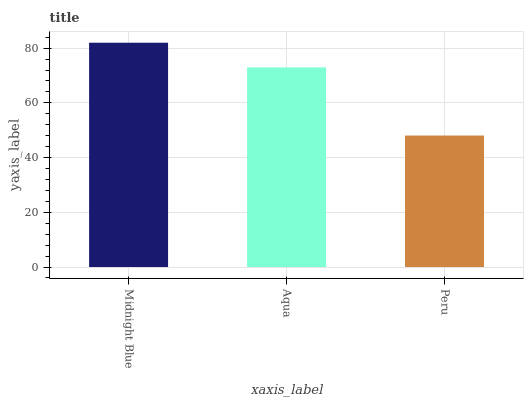Is Peru the minimum?
Answer yes or no. Yes. Is Midnight Blue the maximum?
Answer yes or no. Yes. Is Aqua the minimum?
Answer yes or no. No. Is Aqua the maximum?
Answer yes or no. No. Is Midnight Blue greater than Aqua?
Answer yes or no. Yes. Is Aqua less than Midnight Blue?
Answer yes or no. Yes. Is Aqua greater than Midnight Blue?
Answer yes or no. No. Is Midnight Blue less than Aqua?
Answer yes or no. No. Is Aqua the high median?
Answer yes or no. Yes. Is Aqua the low median?
Answer yes or no. Yes. Is Peru the high median?
Answer yes or no. No. Is Peru the low median?
Answer yes or no. No. 